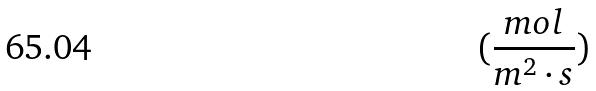<formula> <loc_0><loc_0><loc_500><loc_500>( \frac { m o l } { m ^ { 2 } \cdot s } )</formula> 